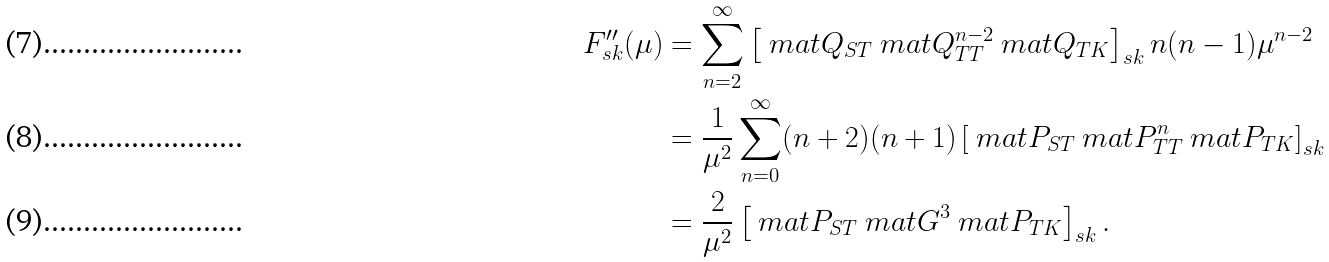Convert formula to latex. <formula><loc_0><loc_0><loc_500><loc_500>F ^ { \prime \prime } _ { s k } ( \mu ) & = \sum _ { n = 2 } ^ { \infty } \left [ \ m a t { Q } _ { S T } \ m a t { Q } ^ { n - 2 } _ { T T } \ m a t { Q } _ { T K } \right ] _ { s k } n ( n - 1 ) \mu ^ { n - 2 } \\ & = \frac { 1 } { \mu ^ { 2 } } \sum _ { n = 0 } ^ { \infty } ( n + 2 ) ( n + 1 ) \left [ \ m a t { P } _ { S T } \ m a t { P } ^ { n } _ { T T } \ m a t { P } _ { T K } \right ] _ { s k } \\ & = \frac { 2 } { \mu ^ { 2 } } \left [ \ m a t { P } _ { S T } \ m a t { G } ^ { 3 } \ m a t { P } _ { T K } \right ] _ { s k } .</formula> 